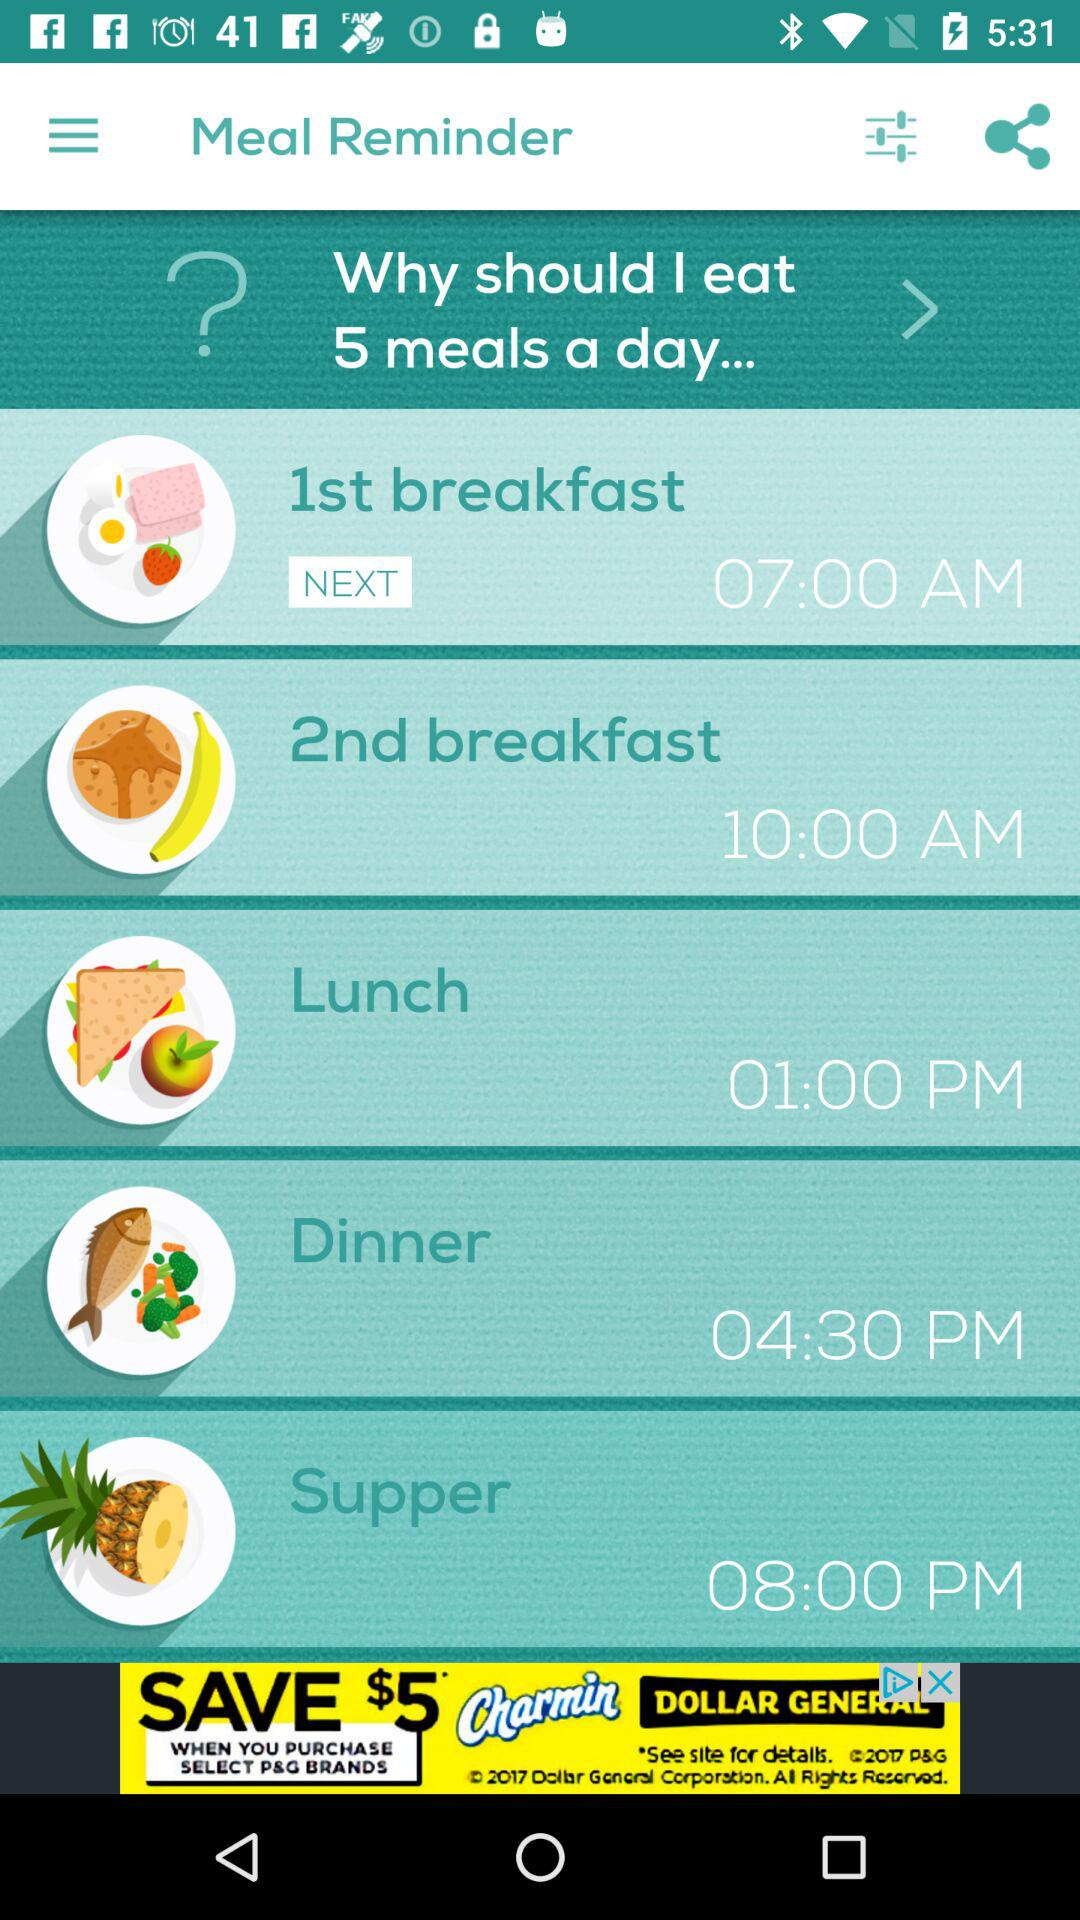At 8:00 pm which activity is scheduled? The activity that is scheduled for 8:00 PM is Supper. 